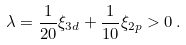Convert formula to latex. <formula><loc_0><loc_0><loc_500><loc_500>\lambda = \frac { 1 } { 2 0 } \xi _ { 3 d } + \frac { 1 } { 1 0 } \xi _ { 2 p } > 0 \, .</formula> 